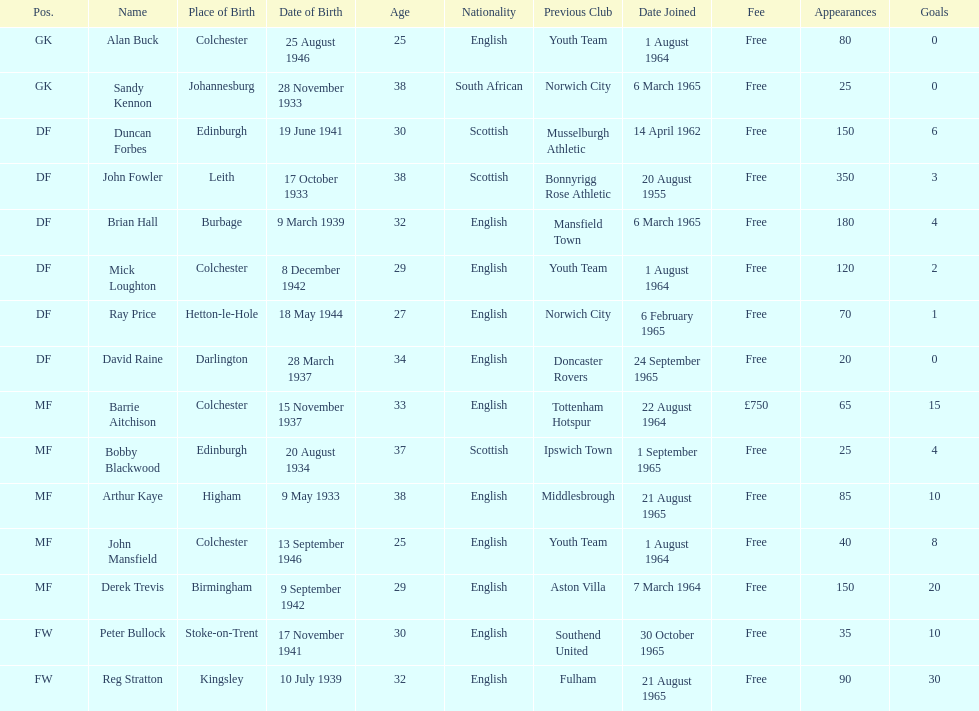I'm looking to parse the entire table for insights. Could you assist me with that? {'header': ['Pos.', 'Name', 'Place of Birth', 'Date of Birth', 'Age', 'Nationality', 'Previous Club', 'Date Joined', 'Fee', 'Appearances', 'Goals'], 'rows': [['GK', 'Alan Buck', 'Colchester', '25 August 1946', '25', 'English', 'Youth Team', '1 August 1964', 'Free', '80', '0'], ['GK', 'Sandy Kennon', 'Johannesburg', '28 November 1933', '38', 'South African', 'Norwich City', '6 March 1965', 'Free', '25', '0'], ['DF', 'Duncan Forbes', 'Edinburgh', '19 June 1941', '30', 'Scottish', 'Musselburgh Athletic', '14 April 1962', 'Free', '150', '6'], ['DF', 'John Fowler', 'Leith', '17 October 1933', '38', 'Scottish', 'Bonnyrigg Rose Athletic', '20 August 1955', 'Free', '350', '3'], ['DF', 'Brian Hall', 'Burbage', '9 March 1939', '32', 'English', 'Mansfield Town', '6 March 1965', 'Free', '180', '4'], ['DF', 'Mick Loughton', 'Colchester', '8 December 1942', '29', 'English', 'Youth Team', '1 August 1964', 'Free', '120', '2'], ['DF', 'Ray Price', 'Hetton-le-Hole', '18 May 1944', '27', 'English', 'Norwich City', '6 February 1965', 'Free', '70', '1'], ['DF', 'David Raine', 'Darlington', '28 March 1937', '34', 'English', 'Doncaster Rovers', '24 September 1965', 'Free', '20', '0'], ['MF', 'Barrie Aitchison', 'Colchester', '15 November 1937', '33', 'English', 'Tottenham Hotspur', '22 August 1964', '£750', '65', '15'], ['MF', 'Bobby Blackwood', 'Edinburgh', '20 August 1934', '37', 'Scottish', 'Ipswich Town', '1 September 1965', 'Free', '25', '4'], ['MF', 'Arthur Kaye', 'Higham', '9 May 1933', '38', 'English', 'Middlesbrough', '21 August 1965', 'Free', '85', '10'], ['MF', 'John Mansfield', 'Colchester', '13 September 1946', '25', 'English', 'Youth Team', '1 August 1964', 'Free', '40', '8'], ['MF', 'Derek Trevis', 'Birmingham', '9 September 1942', '29', 'English', 'Aston Villa', '7 March 1964', 'Free', '150', '20'], ['FW', 'Peter Bullock', 'Stoke-on-Trent', '17 November 1941', '30', 'English', 'Southend United', '30 October 1965', 'Free', '35', '10'], ['FW', 'Reg Stratton', 'Kingsley', '10 July 1939', '32', 'English', 'Fulham', '21 August 1965', 'Free', '90', '30']]} What is the other fee listed, besides free? £750. 